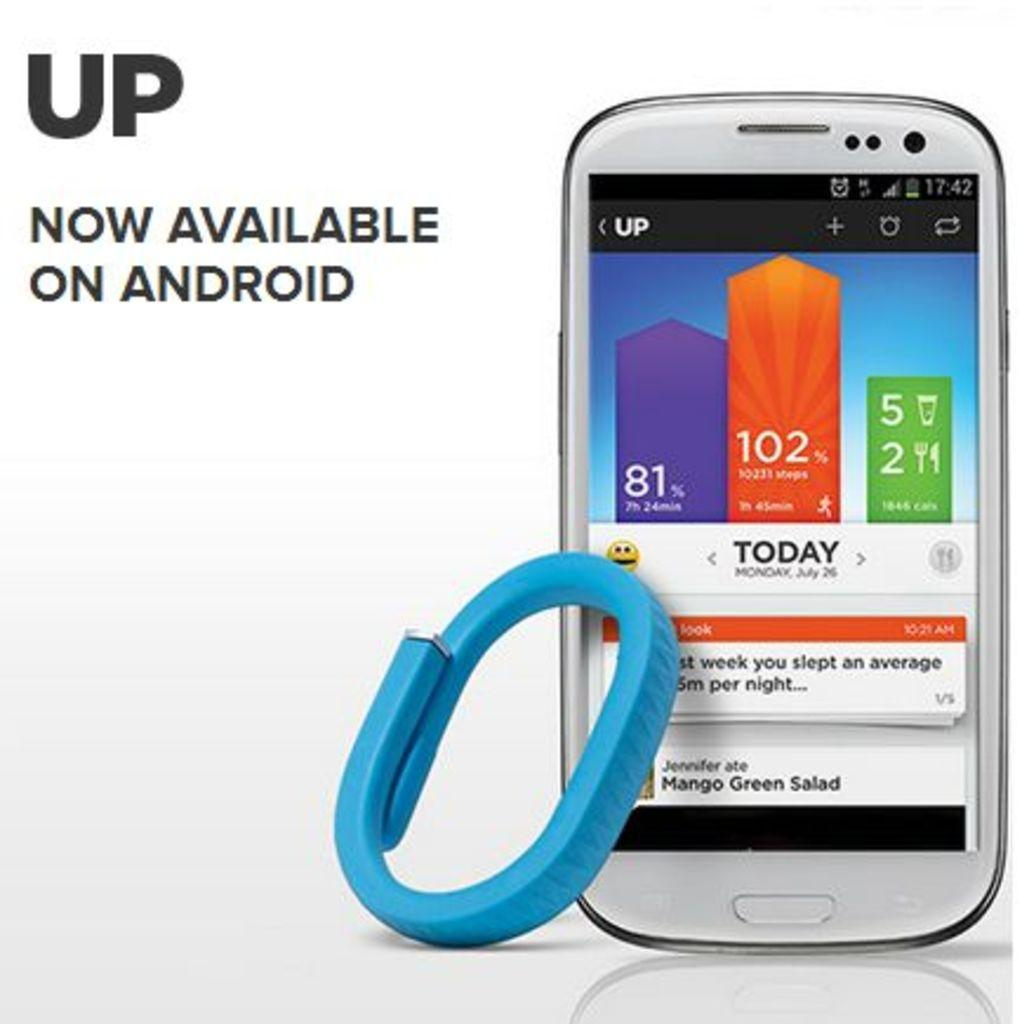<image>
Create a compact narrative representing the image presented. The UP app is now available on android and is shown on the phone. 